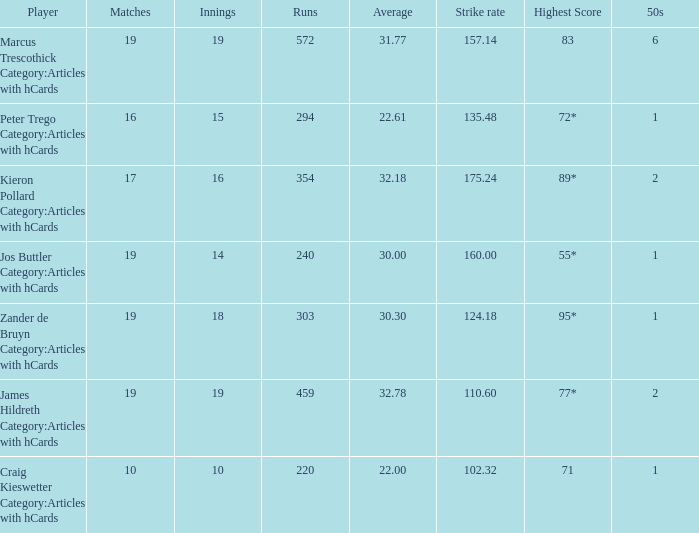Can you give me this table as a dict? {'header': ['Player', 'Matches', 'Innings', 'Runs', 'Average', 'Strike rate', 'Highest Score', '50s'], 'rows': [['Marcus Trescothick Category:Articles with hCards', '19', '19', '572', '31.77', '157.14', '83', '6'], ['Peter Trego Category:Articles with hCards', '16', '15', '294', '22.61', '135.48', '72*', '1'], ['Kieron Pollard Category:Articles with hCards', '17', '16', '354', '32.18', '175.24', '89*', '2'], ['Jos Buttler Category:Articles with hCards', '19', '14', '240', '30.00', '160.00', '55*', '1'], ['Zander de Bruyn Category:Articles with hCards', '19', '18', '303', '30.30', '124.18', '95*', '1'], ['James Hildreth Category:Articles with hCards', '19', '19', '459', '32.78', '110.60', '77*', '2'], ['Craig Kieswetter Category:Articles with hCards', '10', '10', '220', '22.00', '102.32', '71', '1']]} 61 have? 15.0. 